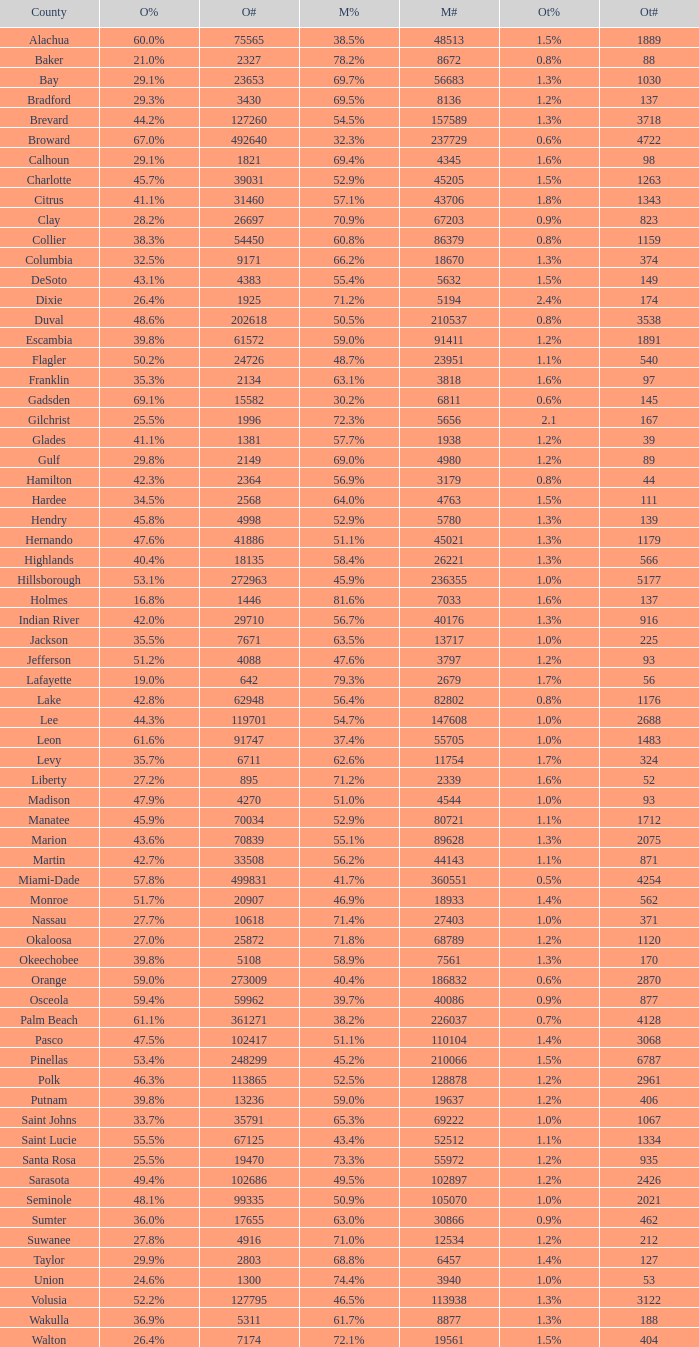9% voters? 1.0. 